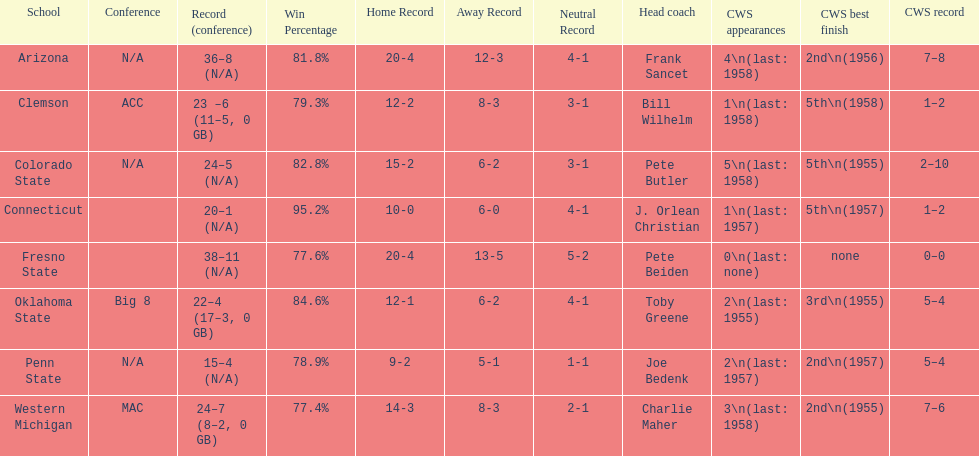Which team did not have more than 16 wins? Penn State. 